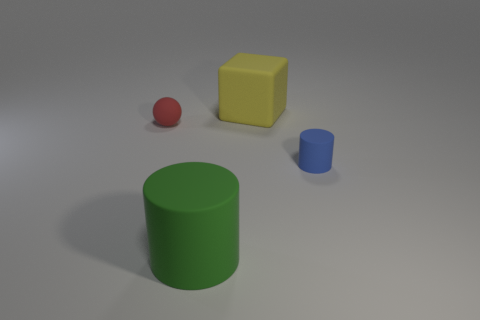The green cylinder has what size?
Offer a terse response. Large. Is there another matte object of the same shape as the small red rubber object?
Provide a succinct answer. No. Do the tiny red thing and the large rubber object in front of the tiny red object have the same shape?
Provide a succinct answer. No. What is the size of the thing that is both to the right of the green rubber cylinder and left of the small blue rubber cylinder?
Give a very brief answer. Large. What number of green things are there?
Your answer should be compact. 1. There is a green cylinder that is the same size as the yellow matte thing; what material is it?
Your answer should be very brief. Rubber. Is there a rubber cylinder of the same size as the yellow matte thing?
Ensure brevity in your answer.  Yes. Does the matte cylinder that is right of the large cube have the same color as the big thing that is behind the tiny red sphere?
Your response must be concise. No. What number of metal things are tiny red things or green cylinders?
Keep it short and to the point. 0. How many small matte things are left of the cylinder to the right of the large matte thing that is to the right of the big green rubber object?
Offer a terse response. 1. 